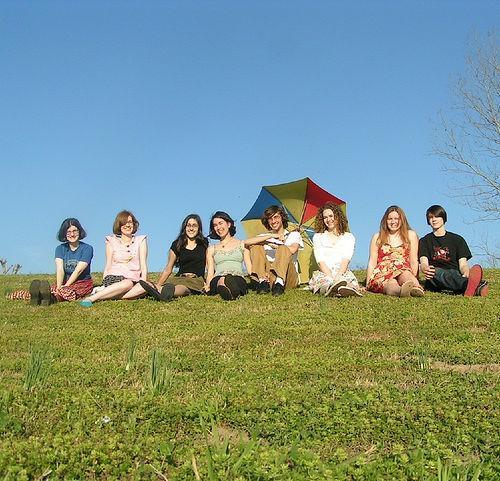How many males are in the picture?
Give a very brief answer. 2. How many people are in the picture?
Give a very brief answer. 8. How many people are there?
Give a very brief answer. 8. 